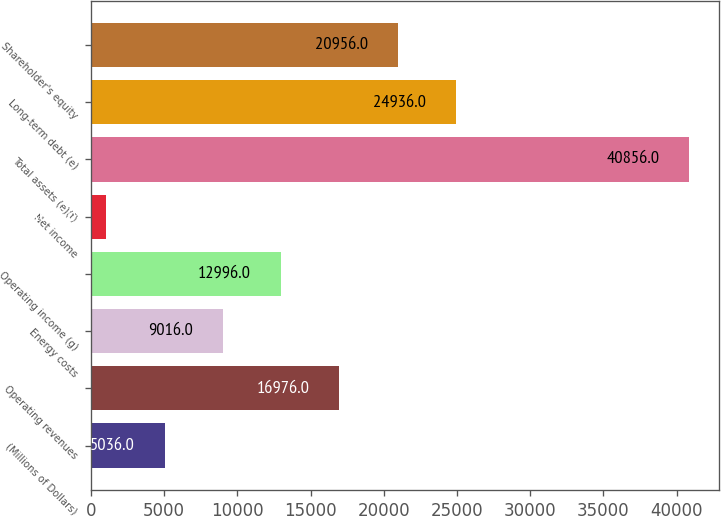Convert chart to OTSL. <chart><loc_0><loc_0><loc_500><loc_500><bar_chart><fcel>(Millions of Dollars)<fcel>Operating revenues<fcel>Energy costs<fcel>Operating income (g)<fcel>Net income<fcel>Total assets (e)(f)<fcel>Long-term debt (e)<fcel>Shareholder's equity<nl><fcel>5036<fcel>16976<fcel>9016<fcel>12996<fcel>1056<fcel>40856<fcel>24936<fcel>20956<nl></chart> 